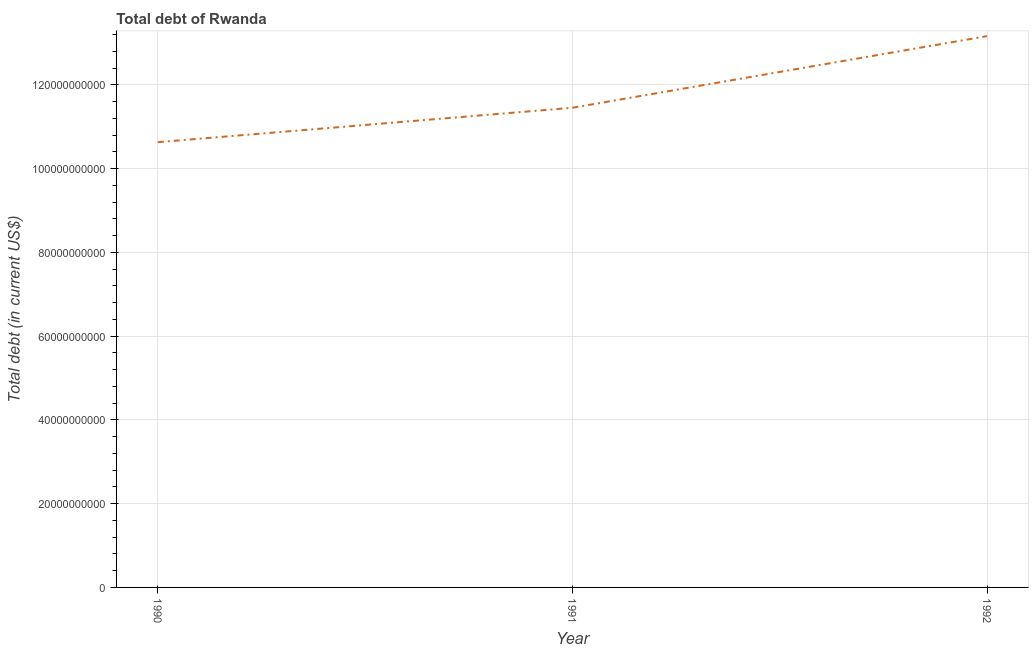What is the total debt in 1992?
Your answer should be very brief. 1.32e+11. Across all years, what is the maximum total debt?
Provide a short and direct response. 1.32e+11. Across all years, what is the minimum total debt?
Provide a succinct answer. 1.06e+11. In which year was the total debt maximum?
Offer a very short reply. 1992. In which year was the total debt minimum?
Your response must be concise. 1990. What is the sum of the total debt?
Your answer should be very brief. 3.52e+11. What is the difference between the total debt in 1990 and 1992?
Provide a short and direct response. -2.53e+1. What is the average total debt per year?
Ensure brevity in your answer.  1.17e+11. What is the median total debt?
Ensure brevity in your answer.  1.15e+11. In how many years, is the total debt greater than 4000000000 US$?
Give a very brief answer. 3. Do a majority of the years between 1990 and 1992 (inclusive) have total debt greater than 112000000000 US$?
Your answer should be compact. Yes. What is the ratio of the total debt in 1990 to that in 1992?
Give a very brief answer. 0.81. Is the difference between the total debt in 1991 and 1992 greater than the difference between any two years?
Give a very brief answer. No. What is the difference between the highest and the second highest total debt?
Your answer should be very brief. 1.71e+1. What is the difference between the highest and the lowest total debt?
Your answer should be very brief. 2.53e+1. How many lines are there?
Provide a short and direct response. 1. How many years are there in the graph?
Make the answer very short. 3. Does the graph contain grids?
Your response must be concise. Yes. What is the title of the graph?
Your response must be concise. Total debt of Rwanda. What is the label or title of the Y-axis?
Give a very brief answer. Total debt (in current US$). What is the Total debt (in current US$) in 1990?
Keep it short and to the point. 1.06e+11. What is the Total debt (in current US$) in 1991?
Provide a short and direct response. 1.15e+11. What is the Total debt (in current US$) of 1992?
Your answer should be very brief. 1.32e+11. What is the difference between the Total debt (in current US$) in 1990 and 1991?
Ensure brevity in your answer.  -8.22e+09. What is the difference between the Total debt (in current US$) in 1990 and 1992?
Provide a short and direct response. -2.53e+1. What is the difference between the Total debt (in current US$) in 1991 and 1992?
Offer a very short reply. -1.71e+1. What is the ratio of the Total debt (in current US$) in 1990 to that in 1991?
Offer a terse response. 0.93. What is the ratio of the Total debt (in current US$) in 1990 to that in 1992?
Ensure brevity in your answer.  0.81. What is the ratio of the Total debt (in current US$) in 1991 to that in 1992?
Offer a very short reply. 0.87. 